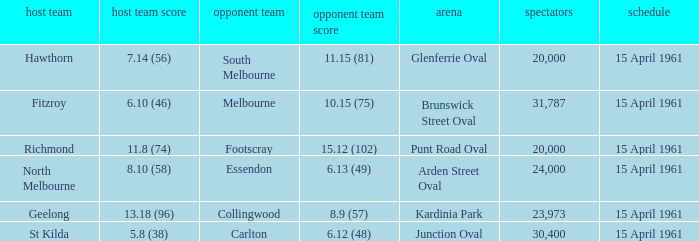What was the score for the home team St Kilda? 5.8 (38). 